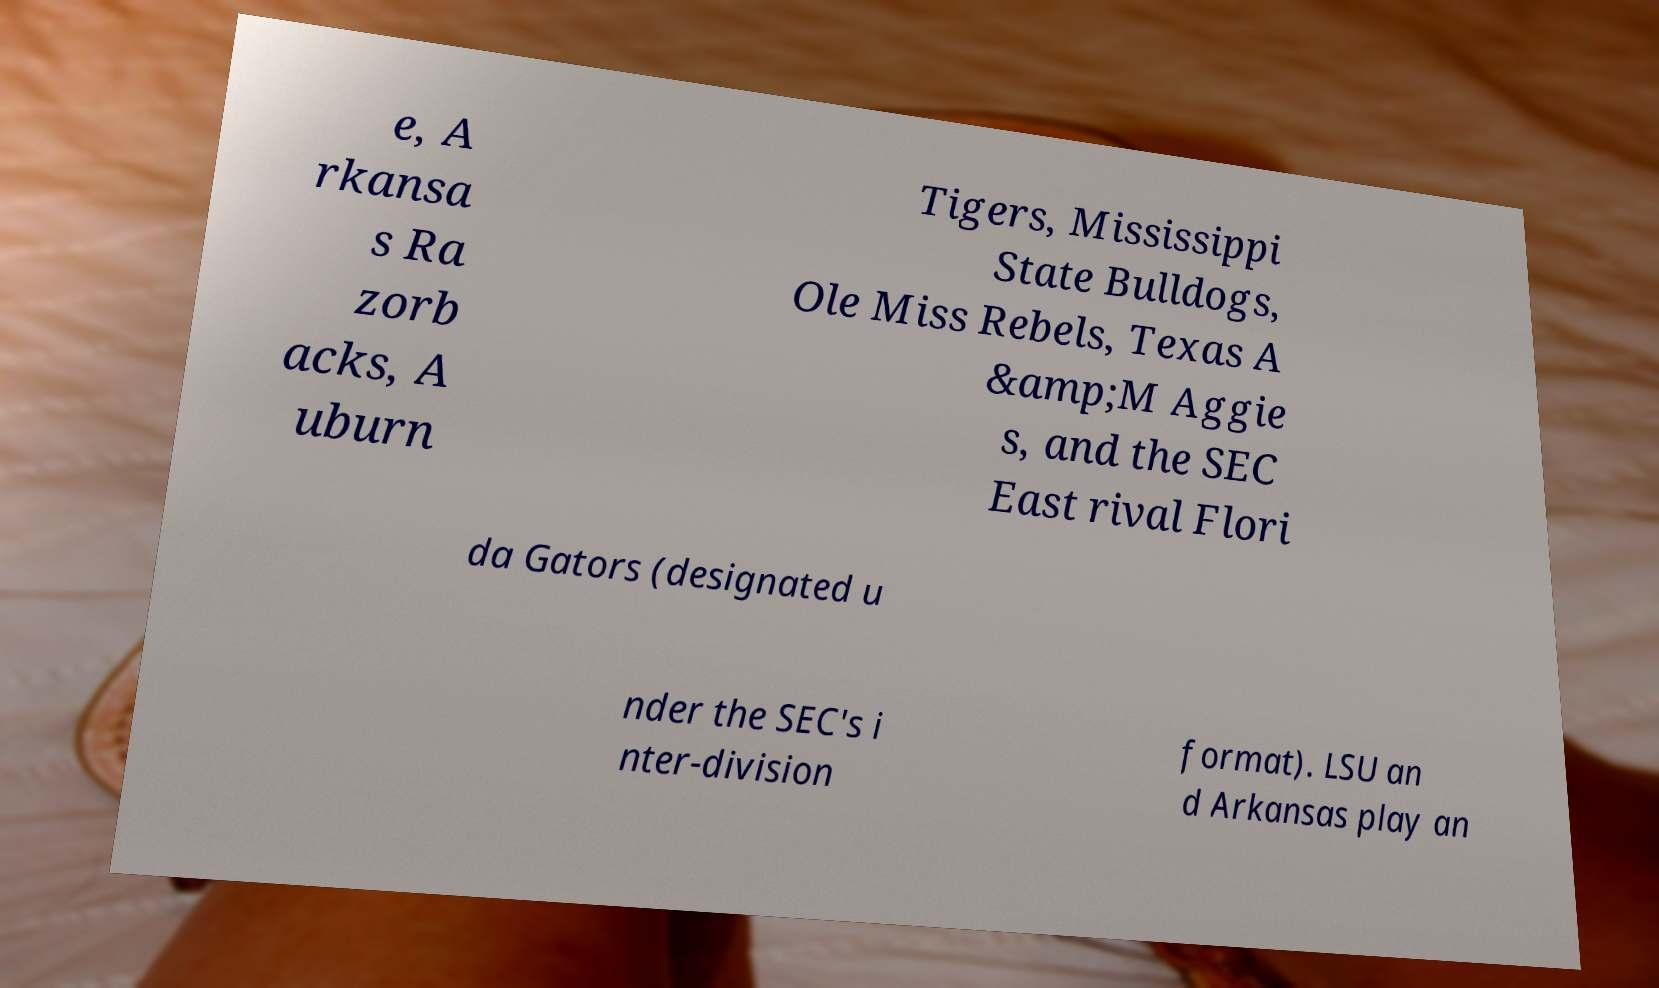For documentation purposes, I need the text within this image transcribed. Could you provide that? e, A rkansa s Ra zorb acks, A uburn Tigers, Mississippi State Bulldogs, Ole Miss Rebels, Texas A &amp;M Aggie s, and the SEC East rival Flori da Gators (designated u nder the SEC's i nter-division format). LSU an d Arkansas play an 